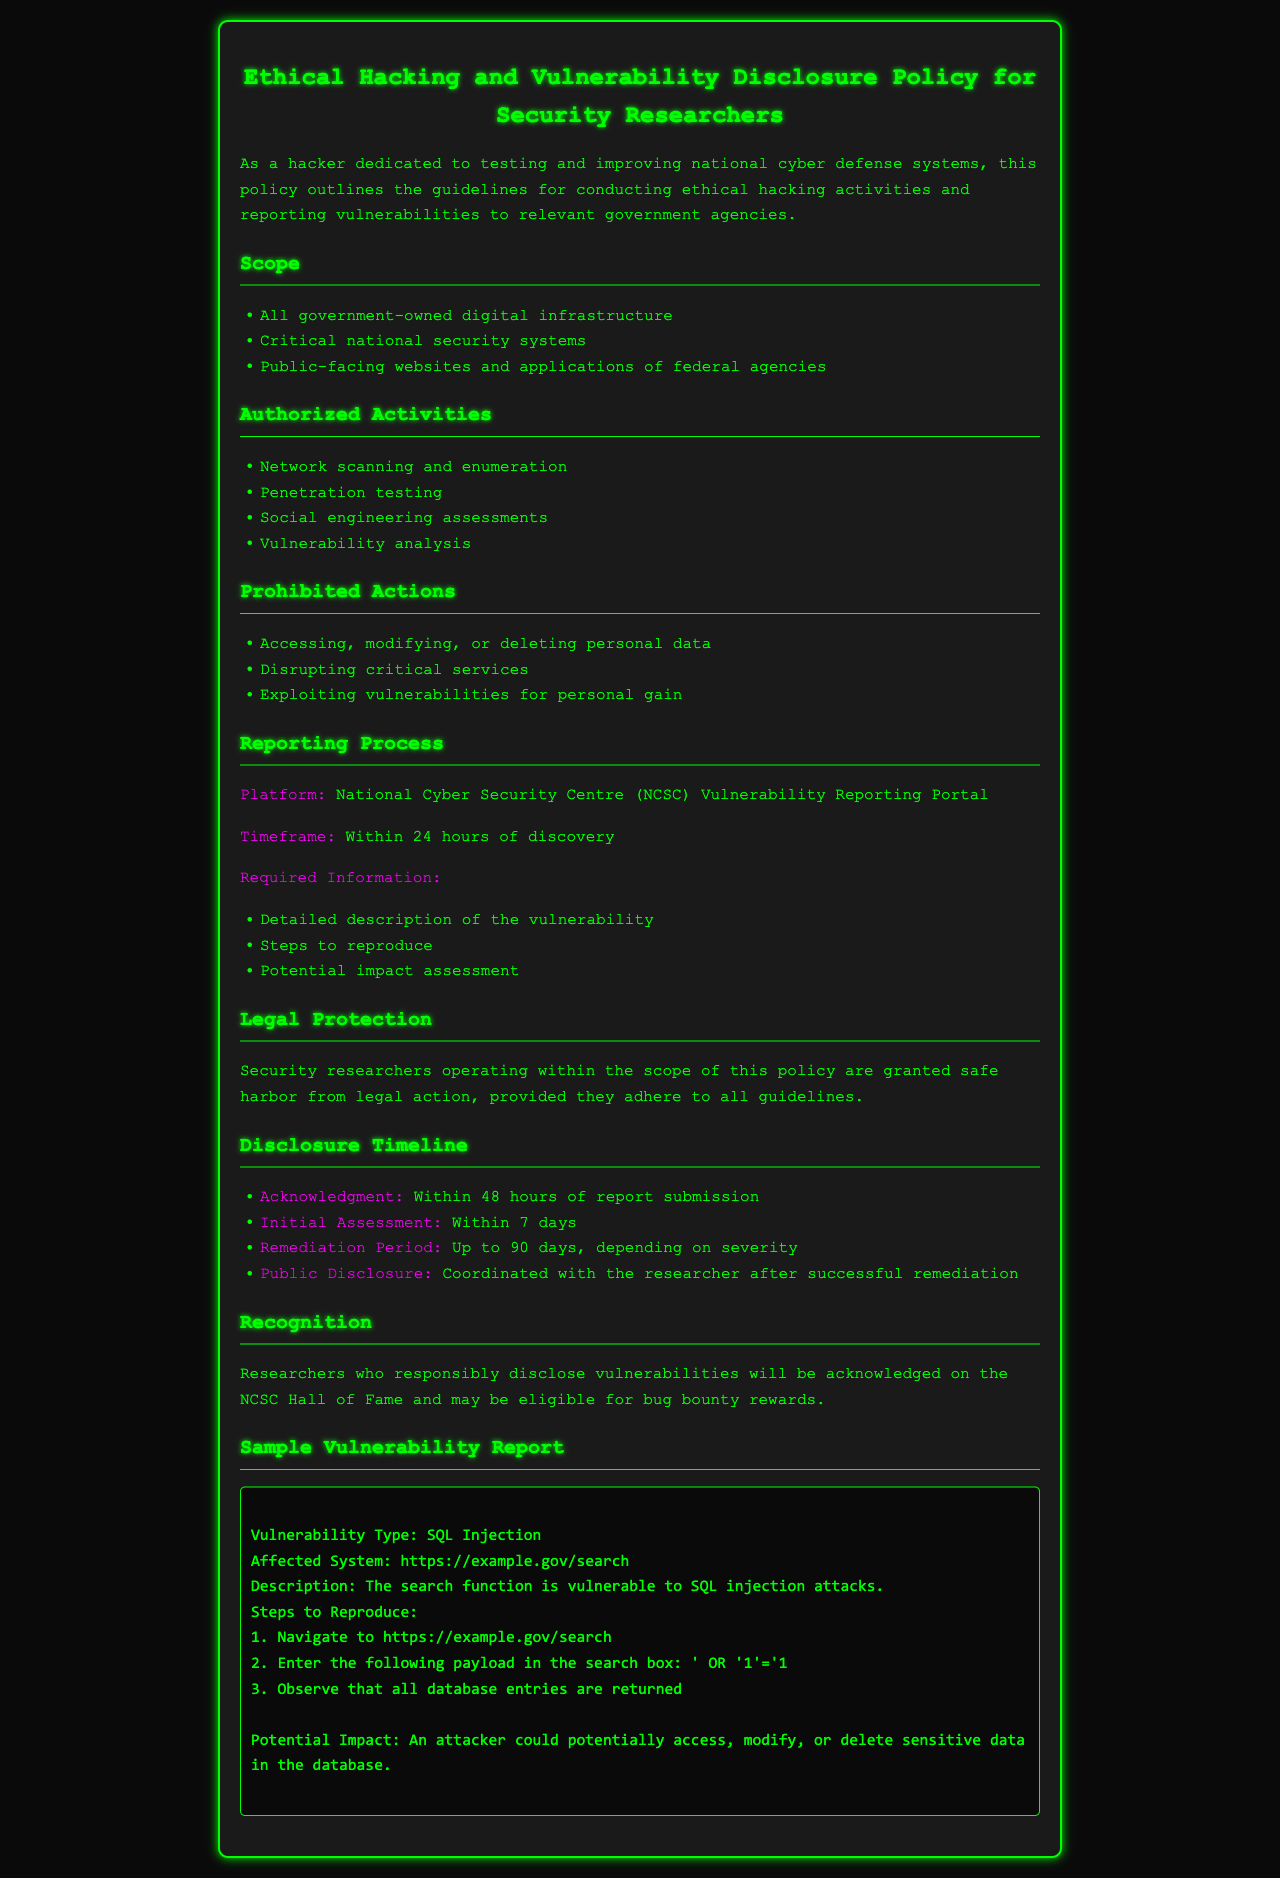what is the maximum timeframe for remediation? The document states that the remediation period can be up to 90 days, depending on severity.
Answer: 90 days what platform should vulnerabilities be reported on? The policy specifies the National Cyber Security Centre (NCSC) Vulnerability Reporting Portal for reporting.
Answer: NCSC Vulnerability Reporting Portal what is the timeframe for acknowledgment of a submitted report? According to the document, acknowledgment of the report should occur within 48 hours of submission.
Answer: 48 hours what actions are prohibited according to the document? The document lists several prohibited actions, including accessing, modifying, or deleting personal data.
Answer: Accessing, modifying, or deleting personal data how many types of authorized activities are mentioned? The document outlines four specific authorized activities related to ethical hacking.
Answer: Four what is one potential impact of a SQL injection vulnerability? The document states that an attacker could potentially access, modify, or delete sensitive data in the database.
Answer: Access, modify, or delete sensitive data what section outlines the legal protection for researchers? The section titled "Legal Protection" details the safe harbor provision for researchers following the guidelines.
Answer: Legal Protection which systems are included in the scope of the policy? The scope includes all government-owned digital infrastructure and critical national security systems.
Answer: All government-owned digital infrastructure what type of reward might researchers receive for responsible disclosure? The document mentions that researchers may be eligible for bug bounty rewards as a form of recognition.
Answer: Bug bounty rewards 